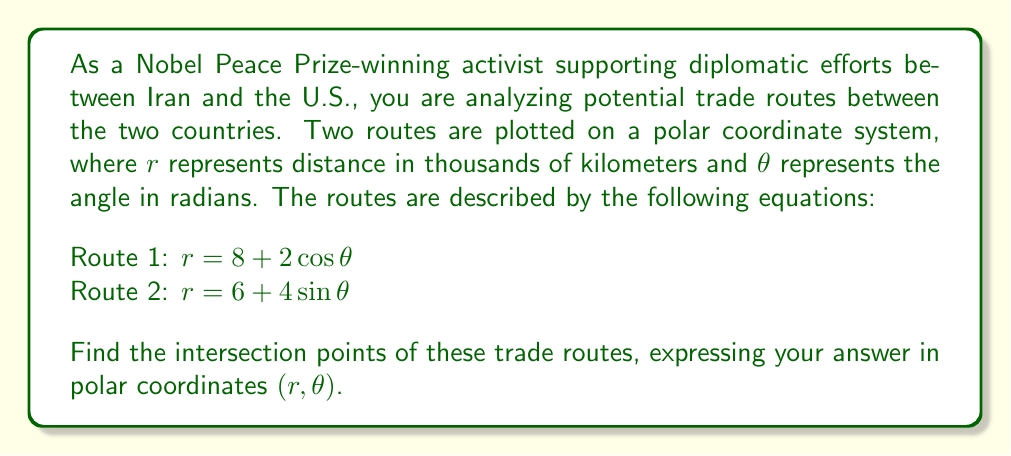Give your solution to this math problem. To find the intersection points, we need to solve the system of equations:

$$\begin{cases}
r = 8 + 2\cos\theta \\
r = 6 + 4\sin\theta
\end{cases}$$

Step 1: Set the equations equal to each other.
$8 + 2\cos\theta = 6 + 4\sin\theta$

Step 2: Rearrange the equation.
$2\cos\theta - 4\sin\theta = -2$

Step 3: Use the trigonometric identity $a\cos\theta + b\sin\theta = R\cos(\theta - \alpha)$, where $R = \sqrt{a^2 + b^2}$ and $\tan\alpha = \frac{b}{a}$.

Here, $a = 2$, $b = -4$, so $R = \sqrt{2^2 + (-4)^2} = \sqrt{20} = 2\sqrt{5}$
$\tan\alpha = \frac{-4}{2} = -2$, so $\alpha = \arctan(-2) \approx -1.107148$

The equation becomes:
$2\sqrt{5}\cos(\theta + 1.107148) = -2$

Step 4: Solve for $\theta$.
$\cos(\theta + 1.107148) = -\frac{1}{\sqrt{5}}$

$\theta + 1.107148 = \pm\arccos(-\frac{1}{\sqrt{5}})$

$\theta = -1.107148 \pm\arccos(-\frac{1}{\sqrt{5}})$

This gives us two solutions:
$\theta_1 \approx 0.7675$ and $\theta_2 \approx 3.9091$

Step 5: Calculate $r$ for each $\theta$ using either of the original equations.
For $\theta_1$: $r_1 = 8 + 2\cos(0.7675) \approx 9.4721$
For $\theta_2$: $r_2 = 8 + 2\cos(3.9091) \approx 6.5279$

Therefore, the intersection points are approximately $(9.4721, 0.7675)$ and $(6.5279, 3.9091)$ in polar coordinates $(r, \theta)$.
Answer: The intersection points of the trade routes are approximately $(9.4721, 0.7675)$ and $(6.5279, 3.9091)$ in polar coordinates $(r, \theta)$, where $r$ is in thousands of kilometers and $\theta$ is in radians. 